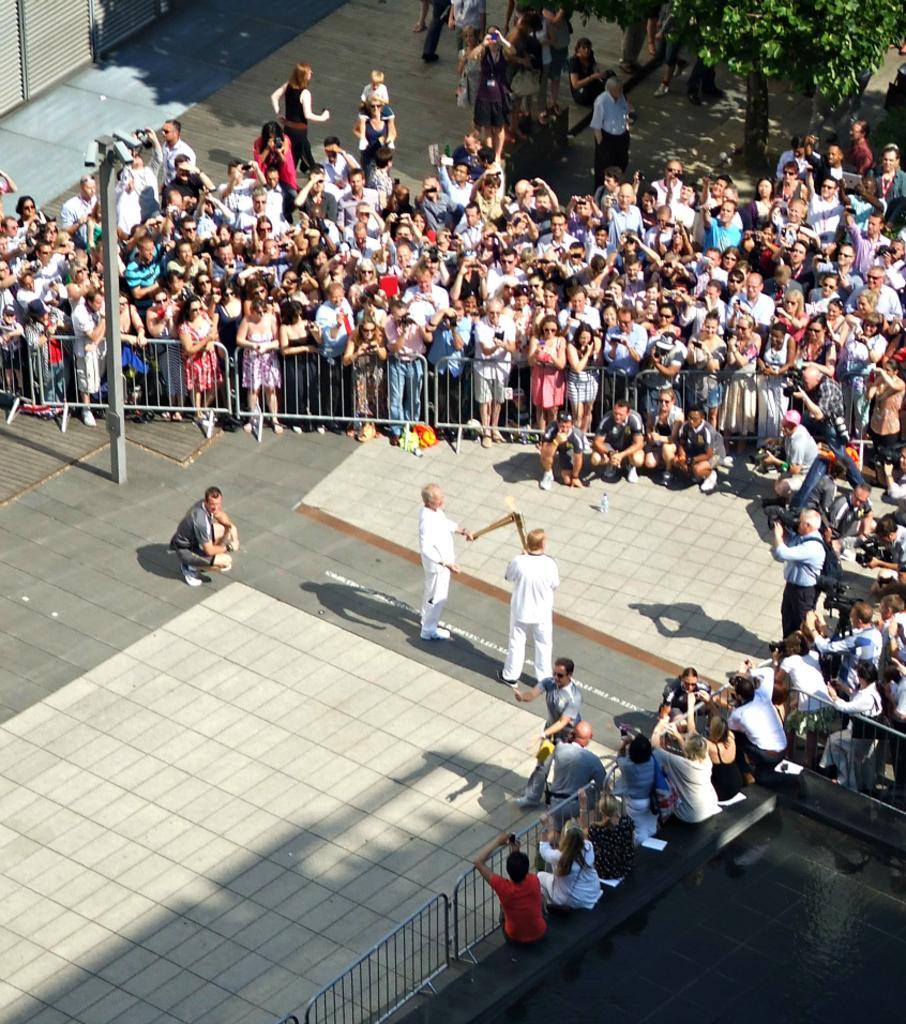In one or two sentences, can you explain what this image depicts? In this image there are two men standing and holding an object, there are group of audience, there is a fencing, there is a pole, there is a tree towards the top of the image, there are shutters towards the top of the image. 